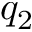<formula> <loc_0><loc_0><loc_500><loc_500>q _ { 2 }</formula> 